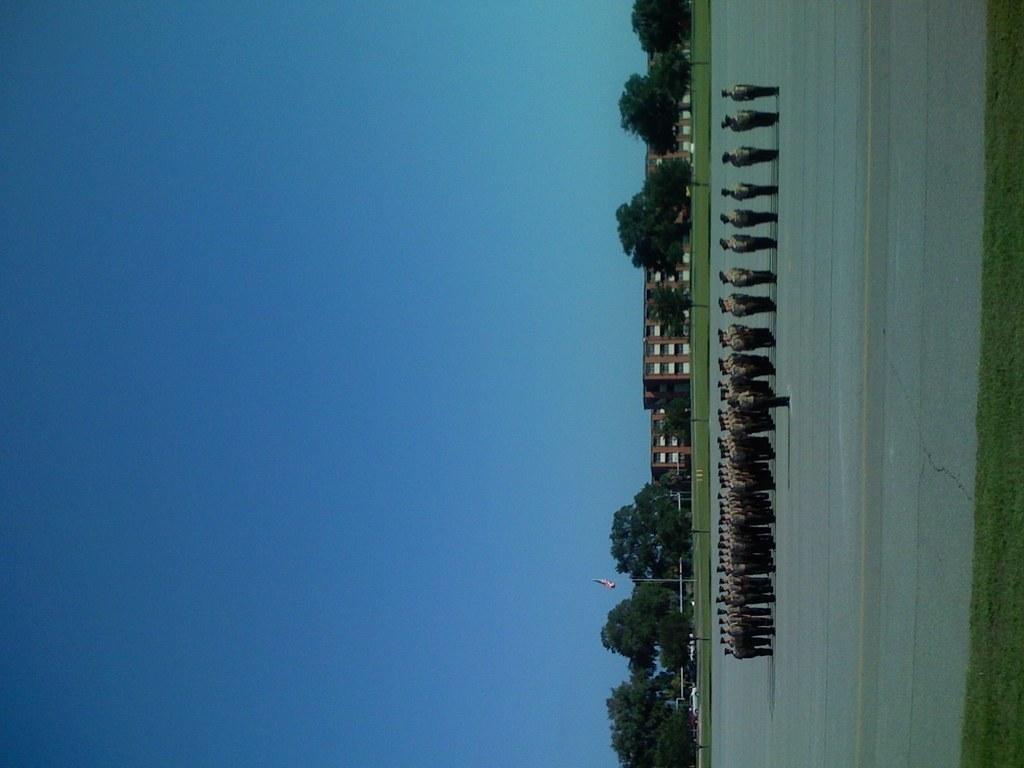How would you summarize this image in a sentence or two? On the right side, there are persons in uniform, standing in the rows on a road. Beside this road, there is grass on the ground. In the background, there are trees, buildings and there is blue sky. 